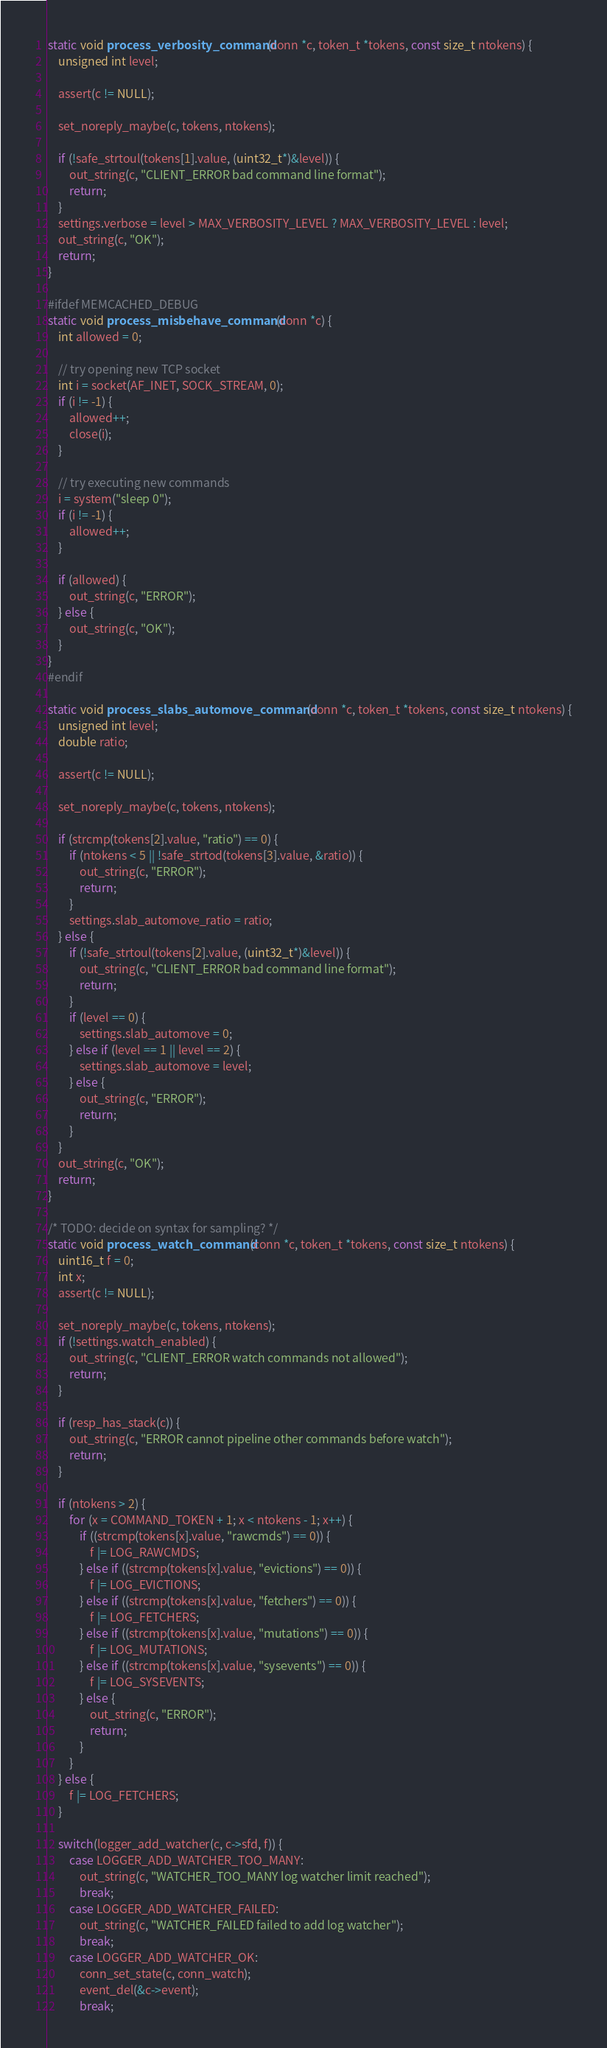<code> <loc_0><loc_0><loc_500><loc_500><_C_>static void process_verbosity_command(conn *c, token_t *tokens, const size_t ntokens) {
    unsigned int level;

    assert(c != NULL);

    set_noreply_maybe(c, tokens, ntokens);

    if (!safe_strtoul(tokens[1].value, (uint32_t*)&level)) {
        out_string(c, "CLIENT_ERROR bad command line format");
        return;
    }
    settings.verbose = level > MAX_VERBOSITY_LEVEL ? MAX_VERBOSITY_LEVEL : level;
    out_string(c, "OK");
    return;
}

#ifdef MEMCACHED_DEBUG
static void process_misbehave_command(conn *c) {
    int allowed = 0;

    // try opening new TCP socket
    int i = socket(AF_INET, SOCK_STREAM, 0);
    if (i != -1) {
        allowed++;
        close(i);
    }

    // try executing new commands
    i = system("sleep 0");
    if (i != -1) {
        allowed++;
    }

    if (allowed) {
        out_string(c, "ERROR");
    } else {
        out_string(c, "OK");
    }
}
#endif

static void process_slabs_automove_command(conn *c, token_t *tokens, const size_t ntokens) {
    unsigned int level;
    double ratio;

    assert(c != NULL);

    set_noreply_maybe(c, tokens, ntokens);

    if (strcmp(tokens[2].value, "ratio") == 0) {
        if (ntokens < 5 || !safe_strtod(tokens[3].value, &ratio)) {
            out_string(c, "ERROR");
            return;
        }
        settings.slab_automove_ratio = ratio;
    } else {
        if (!safe_strtoul(tokens[2].value, (uint32_t*)&level)) {
            out_string(c, "CLIENT_ERROR bad command line format");
            return;
        }
        if (level == 0) {
            settings.slab_automove = 0;
        } else if (level == 1 || level == 2) {
            settings.slab_automove = level;
        } else {
            out_string(c, "ERROR");
            return;
        }
    }
    out_string(c, "OK");
    return;
}

/* TODO: decide on syntax for sampling? */
static void process_watch_command(conn *c, token_t *tokens, const size_t ntokens) {
    uint16_t f = 0;
    int x;
    assert(c != NULL);

    set_noreply_maybe(c, tokens, ntokens);
    if (!settings.watch_enabled) {
        out_string(c, "CLIENT_ERROR watch commands not allowed");
        return;
    }

    if (resp_has_stack(c)) {
        out_string(c, "ERROR cannot pipeline other commands before watch");
        return;
    }

    if (ntokens > 2) {
        for (x = COMMAND_TOKEN + 1; x < ntokens - 1; x++) {
            if ((strcmp(tokens[x].value, "rawcmds") == 0)) {
                f |= LOG_RAWCMDS;
            } else if ((strcmp(tokens[x].value, "evictions") == 0)) {
                f |= LOG_EVICTIONS;
            } else if ((strcmp(tokens[x].value, "fetchers") == 0)) {
                f |= LOG_FETCHERS;
            } else if ((strcmp(tokens[x].value, "mutations") == 0)) {
                f |= LOG_MUTATIONS;
            } else if ((strcmp(tokens[x].value, "sysevents") == 0)) {
                f |= LOG_SYSEVENTS;
            } else {
                out_string(c, "ERROR");
                return;
            }
        }
    } else {
        f |= LOG_FETCHERS;
    }

    switch(logger_add_watcher(c, c->sfd, f)) {
        case LOGGER_ADD_WATCHER_TOO_MANY:
            out_string(c, "WATCHER_TOO_MANY log watcher limit reached");
            break;
        case LOGGER_ADD_WATCHER_FAILED:
            out_string(c, "WATCHER_FAILED failed to add log watcher");
            break;
        case LOGGER_ADD_WATCHER_OK:
            conn_set_state(c, conn_watch);
            event_del(&c->event);
            break;</code> 